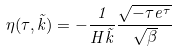<formula> <loc_0><loc_0><loc_500><loc_500>\eta ( \tau , \tilde { k } ) = - \frac { 1 } { H \tilde { k } } \frac { \sqrt { - \tau e ^ { \tau } } } { \sqrt { \beta } }</formula> 